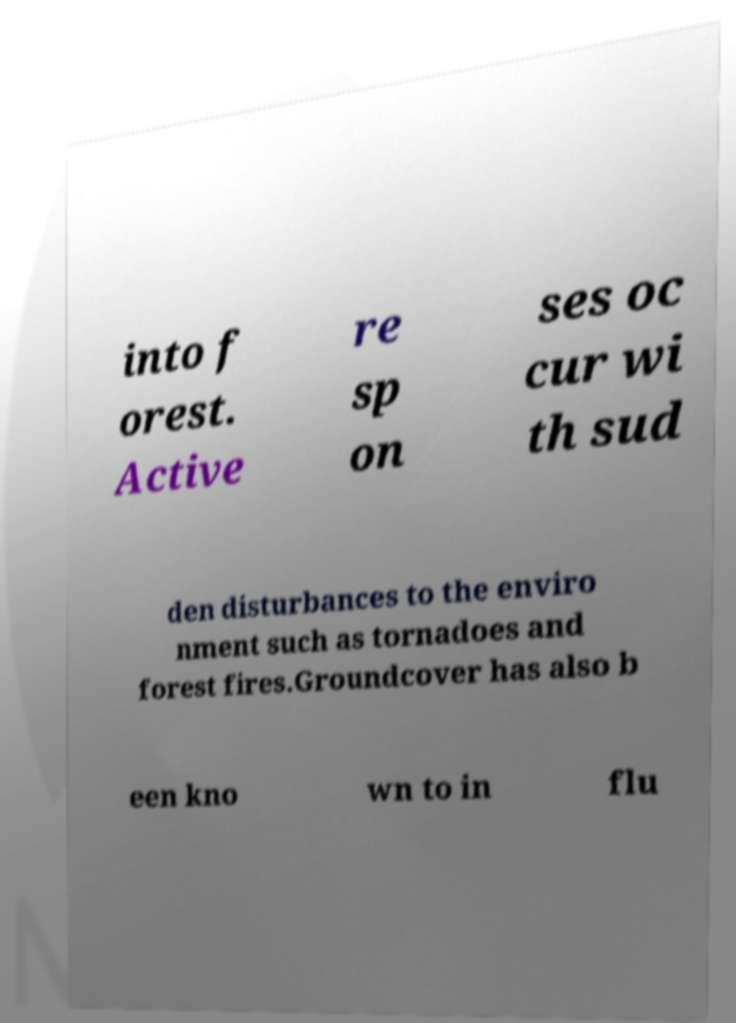What messages or text are displayed in this image? I need them in a readable, typed format. into f orest. Active re sp on ses oc cur wi th sud den disturbances to the enviro nment such as tornadoes and forest fires.Groundcover has also b een kno wn to in flu 